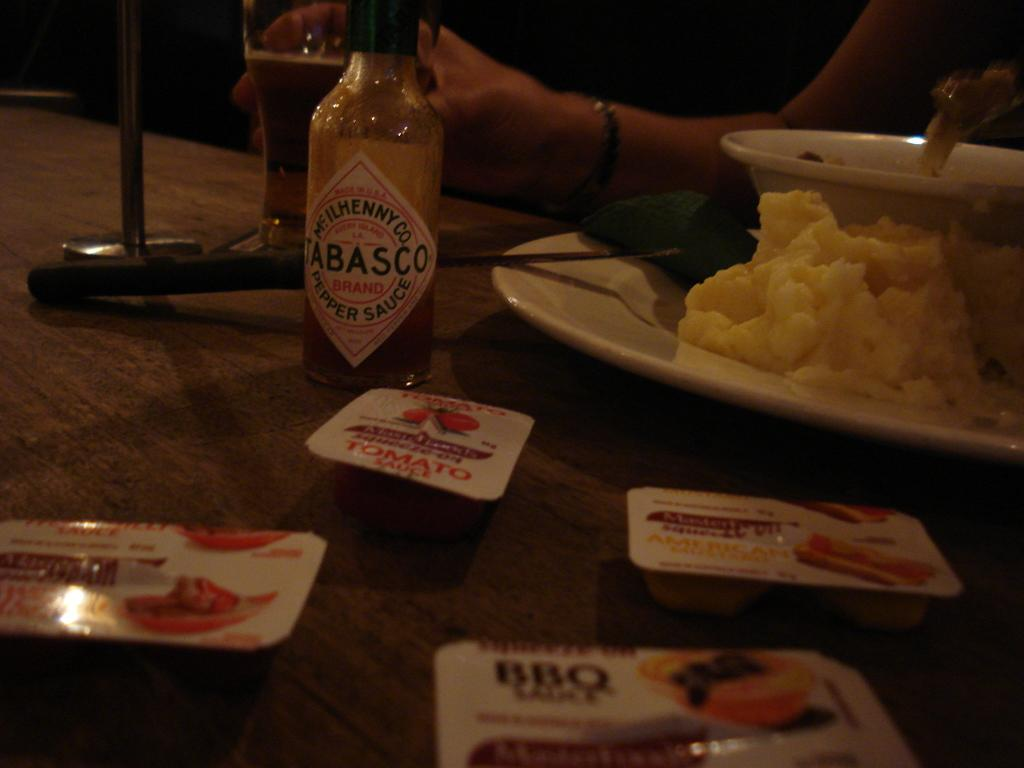<image>
Present a compact description of the photo's key features. A bottle of Tabasco sauce is on a table with a plate of mashed potatoes. 